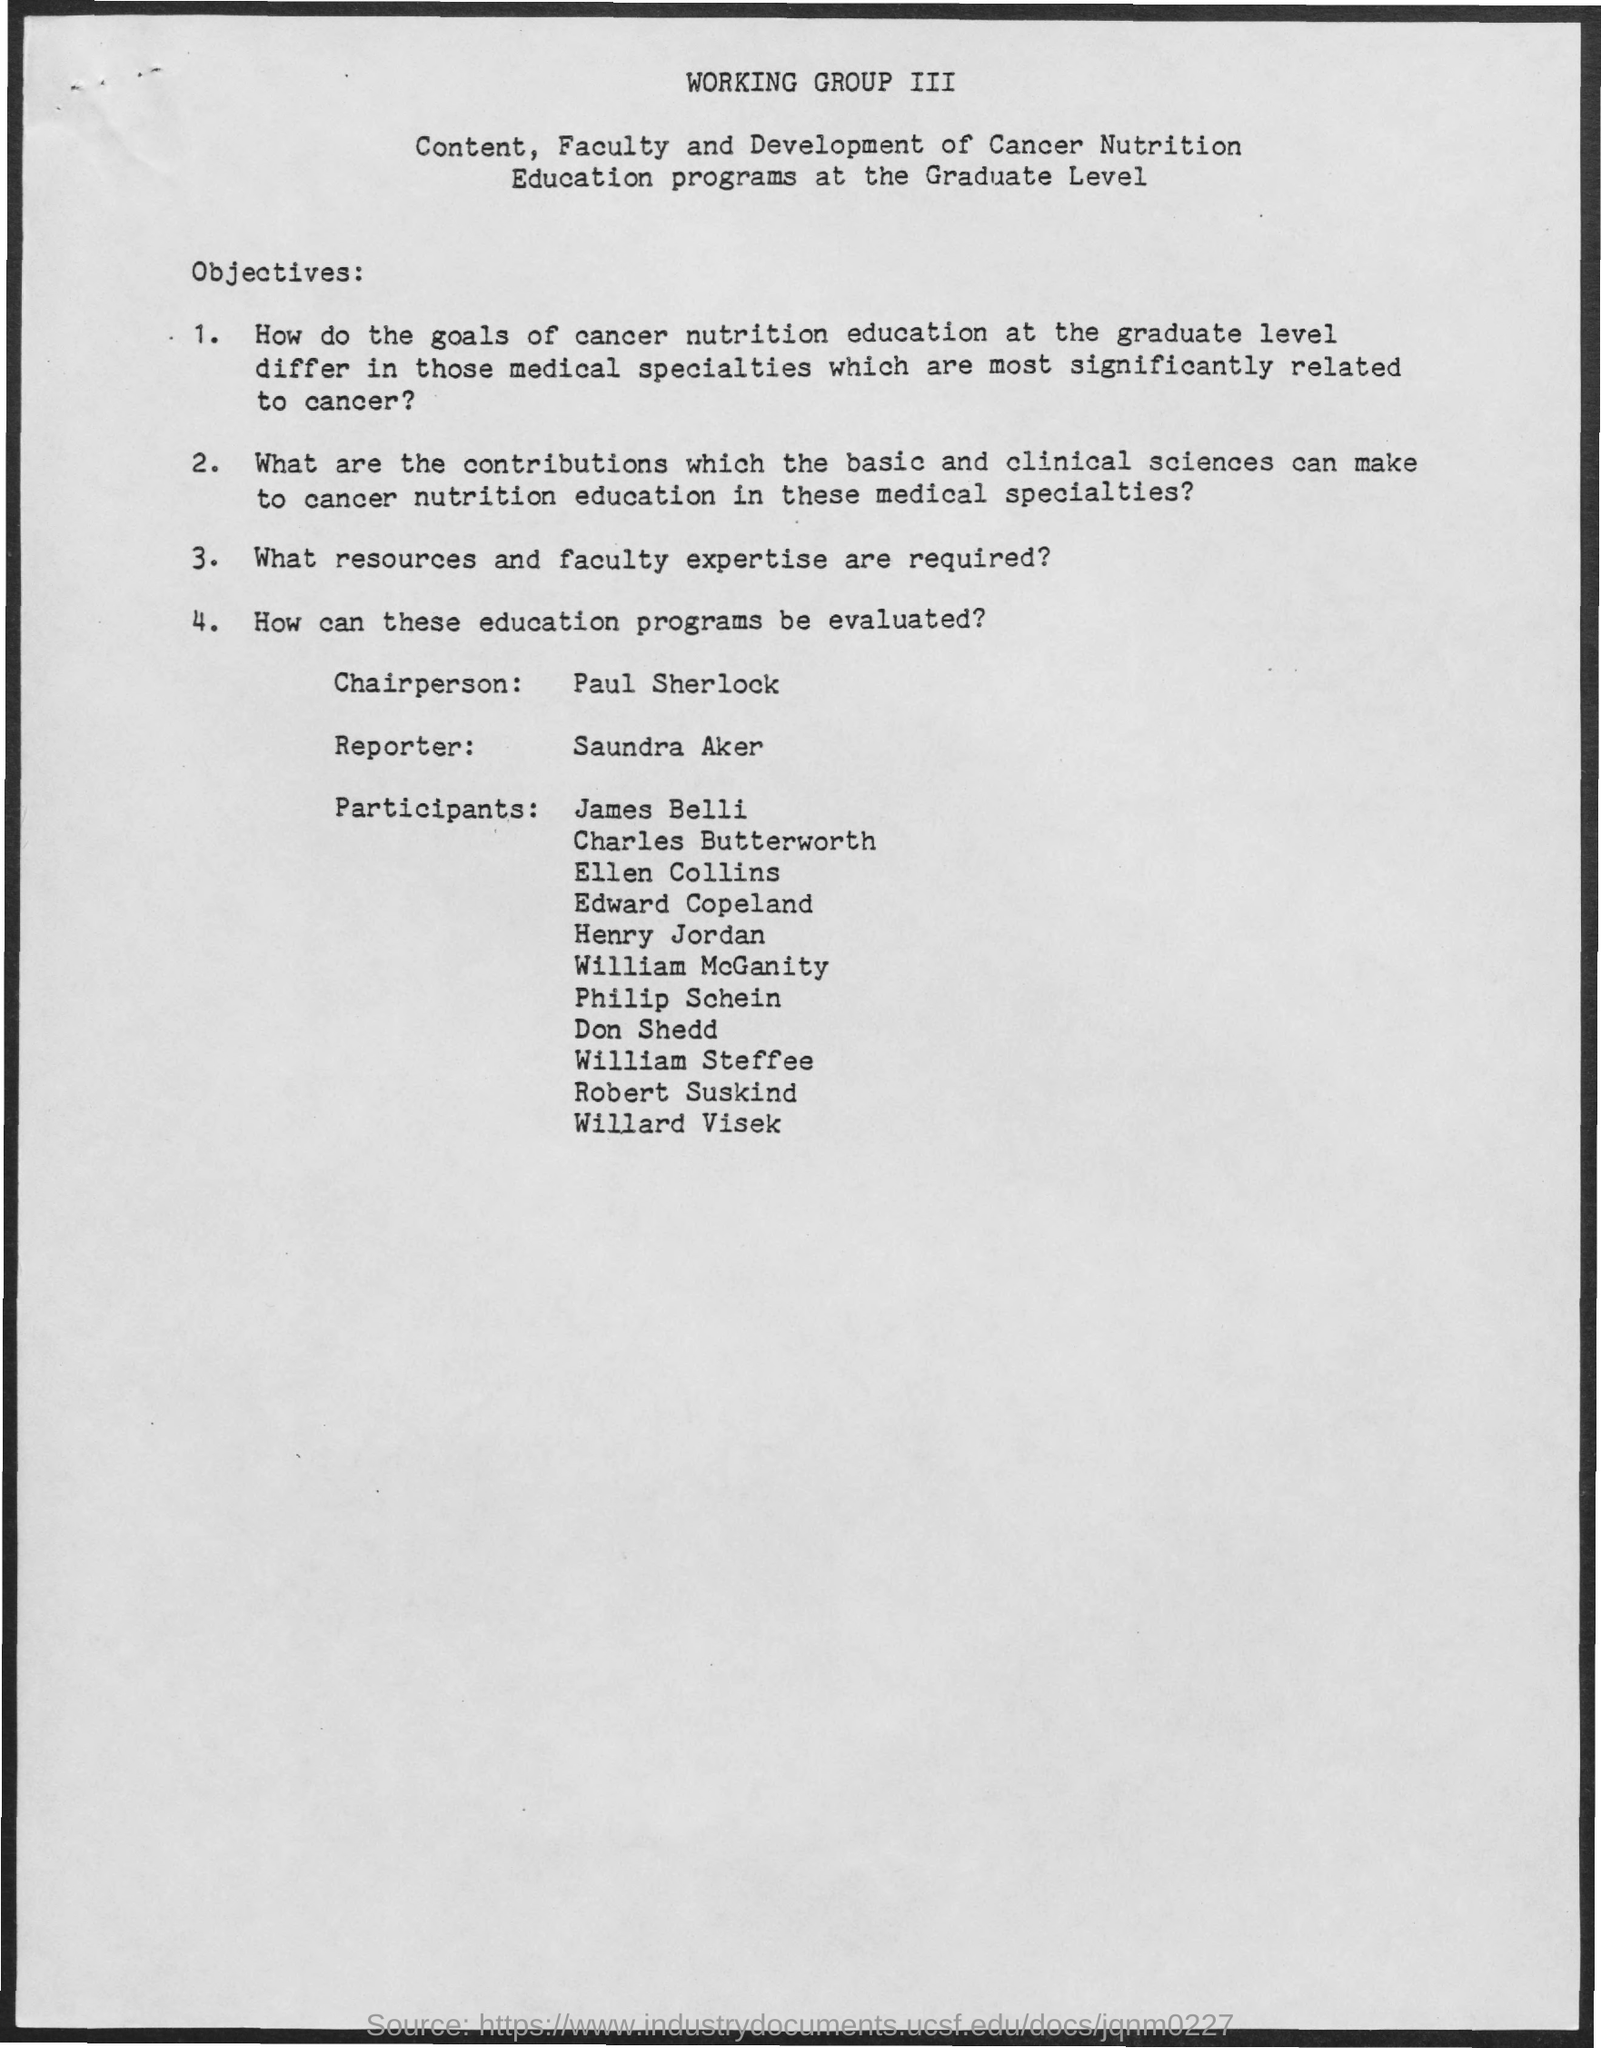What is the name of the chairperson mentioned in the given page ?
Offer a very short reply. Paul Sherlock. What is the name of the reporter mentioned in the given page ?
Provide a short and direct response. Saundra aker. 